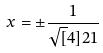Convert formula to latex. <formula><loc_0><loc_0><loc_500><loc_500>x = \pm \frac { 1 } { \sqrt { [ } 4 ] { 2 1 } }</formula> 